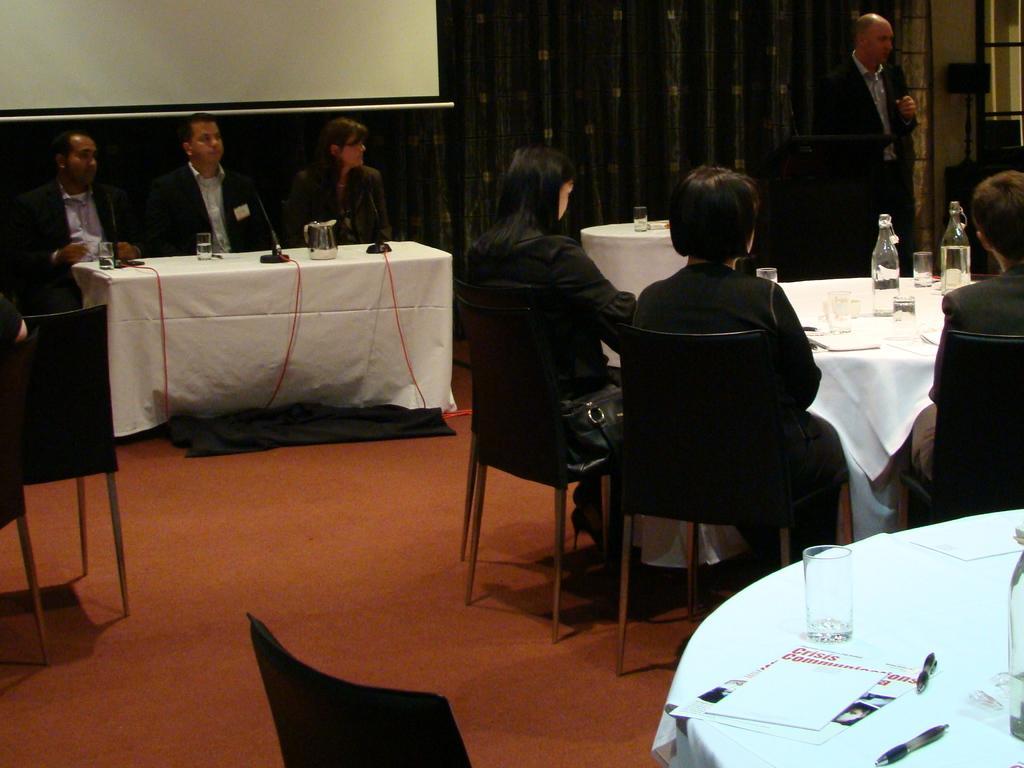How would you summarize this image in a sentence or two? The image is taken in the room. There are tables. There are chairs. We can see people sitting around the tables. On table there is a glass, bottle, pens, papers, jugs and wires. In the center of the room there is a man standing and talking before him there is a podium. In the background there is a screen and a curtain. 